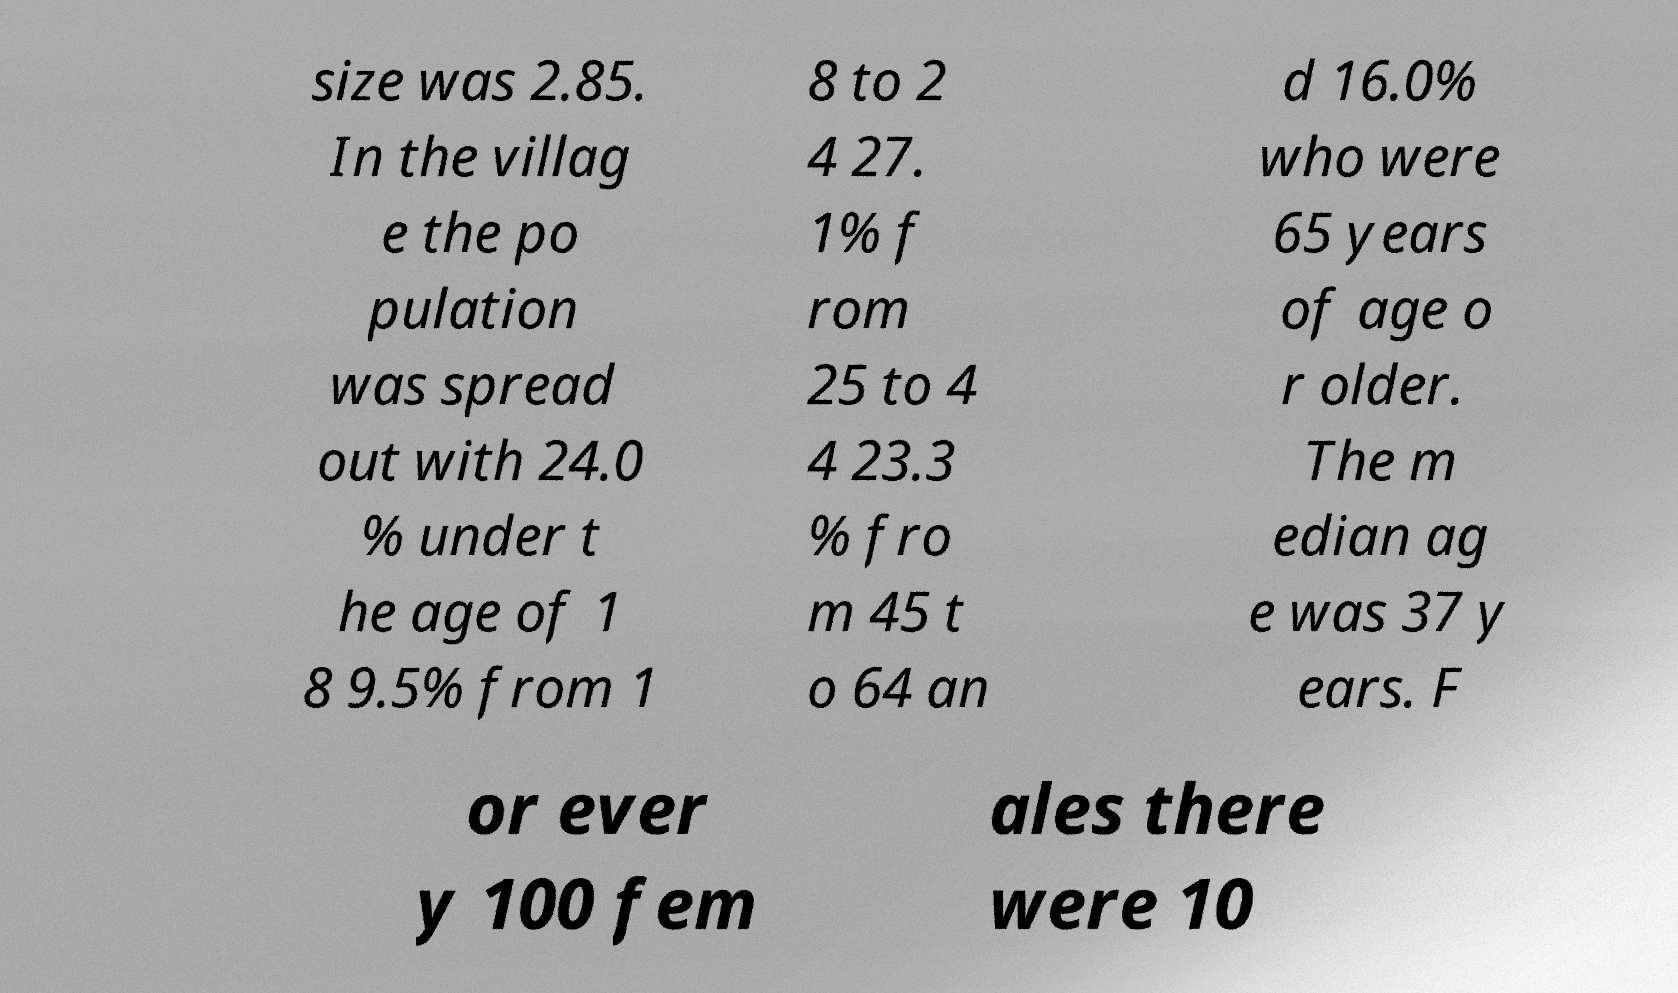Could you extract and type out the text from this image? size was 2.85. In the villag e the po pulation was spread out with 24.0 % under t he age of 1 8 9.5% from 1 8 to 2 4 27. 1% f rom 25 to 4 4 23.3 % fro m 45 t o 64 an d 16.0% who were 65 years of age o r older. The m edian ag e was 37 y ears. F or ever y 100 fem ales there were 10 